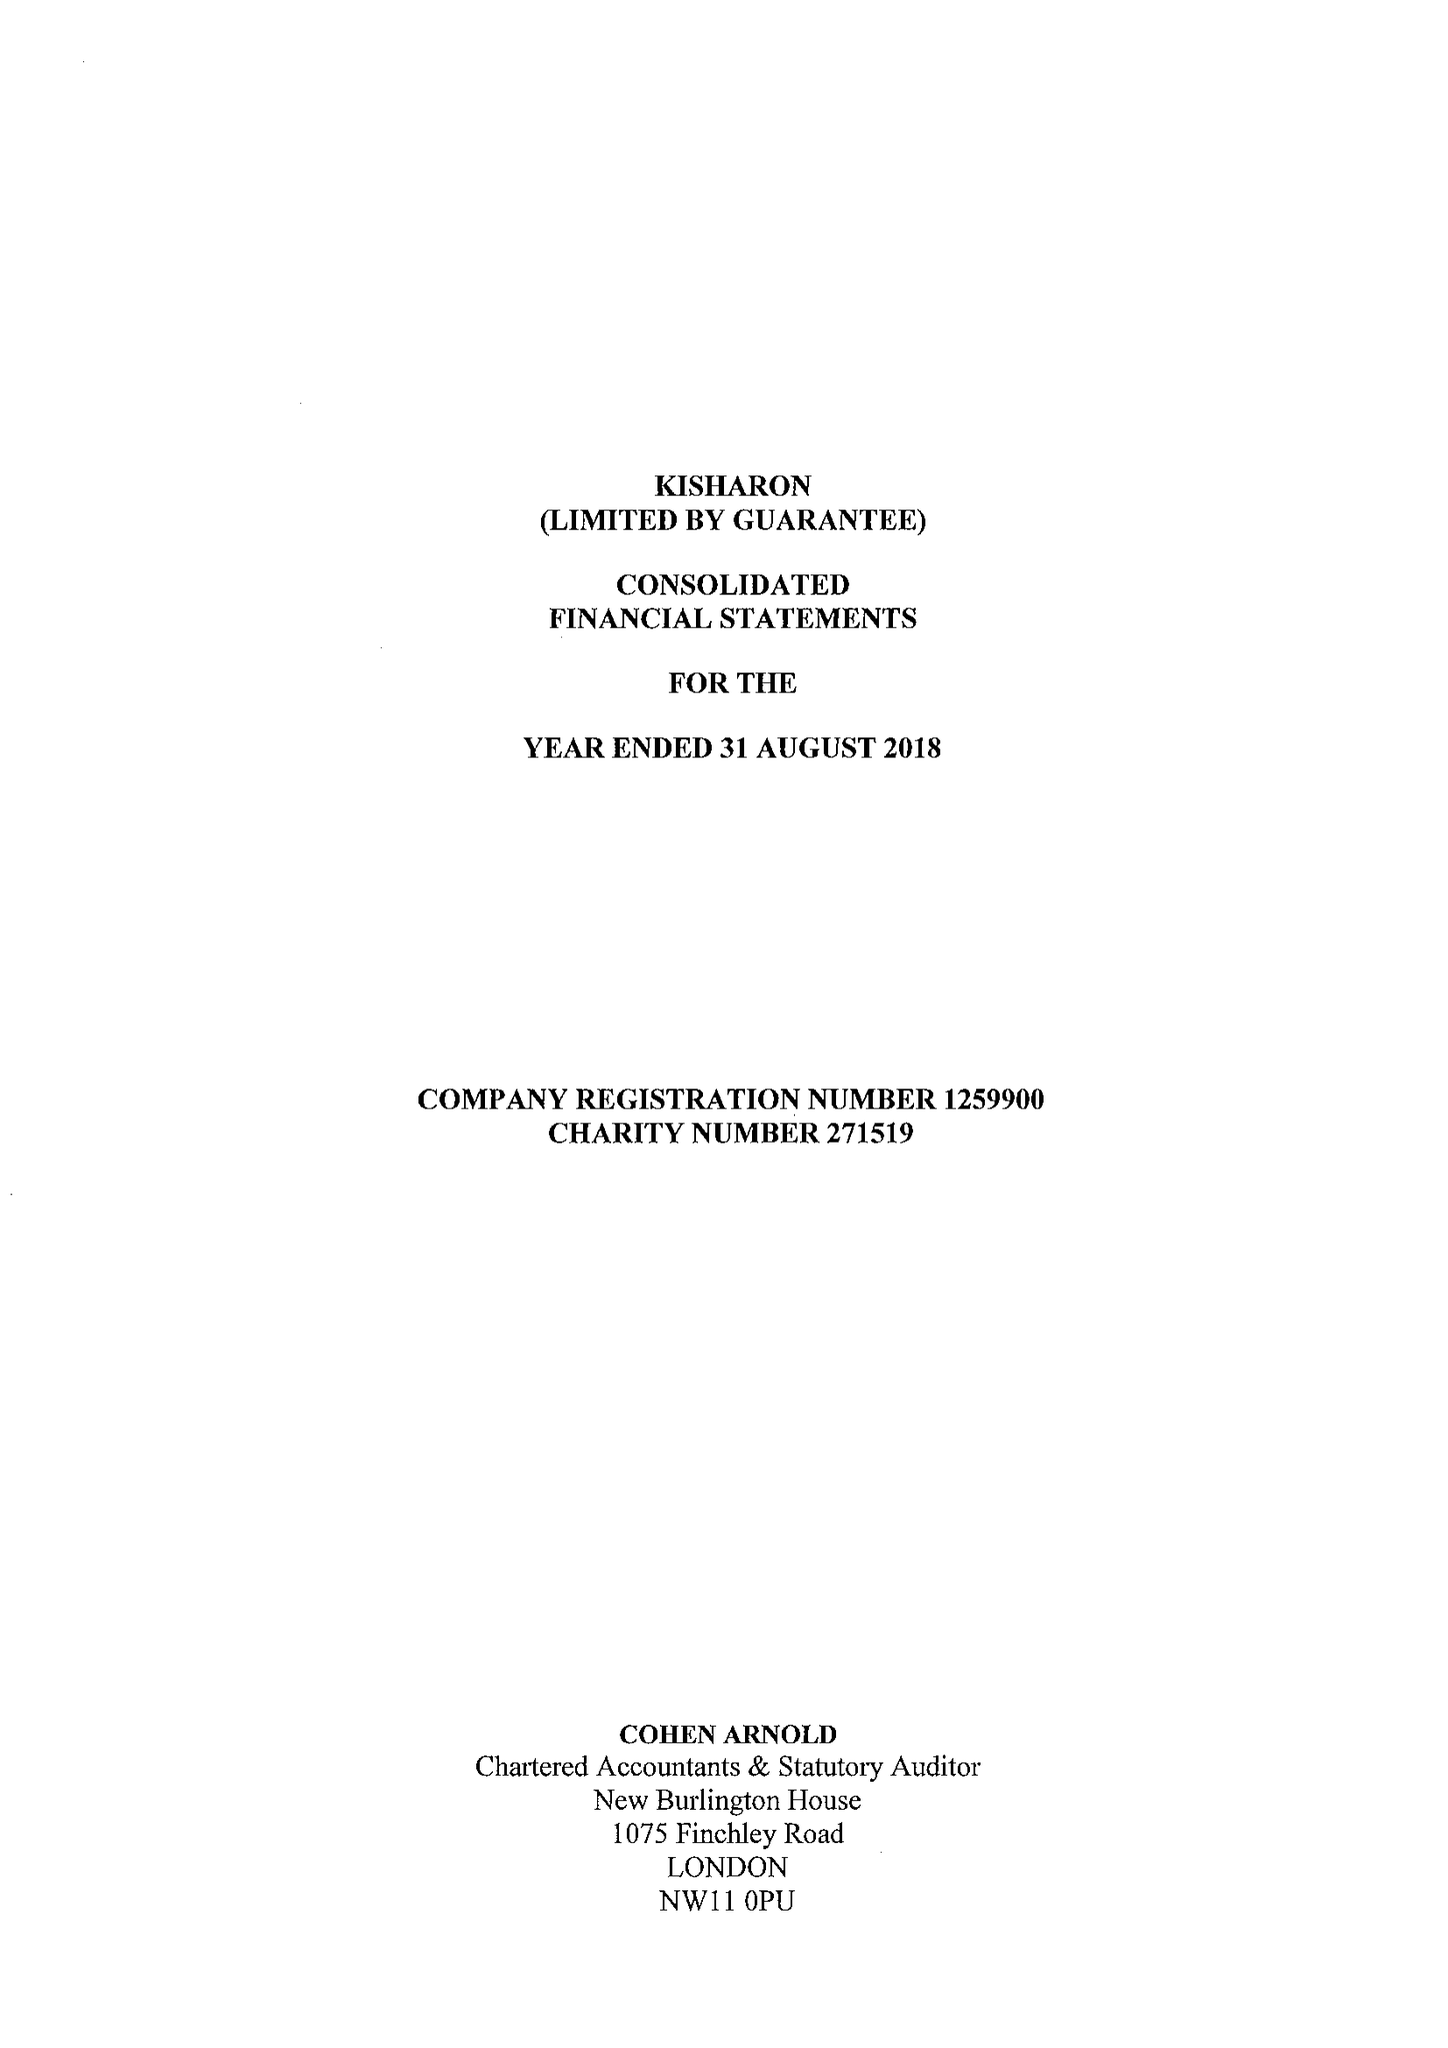What is the value for the income_annually_in_british_pounds?
Answer the question using a single word or phrase. 10979966.00 